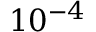Convert formula to latex. <formula><loc_0><loc_0><loc_500><loc_500>1 0 ^ { - 4 }</formula> 